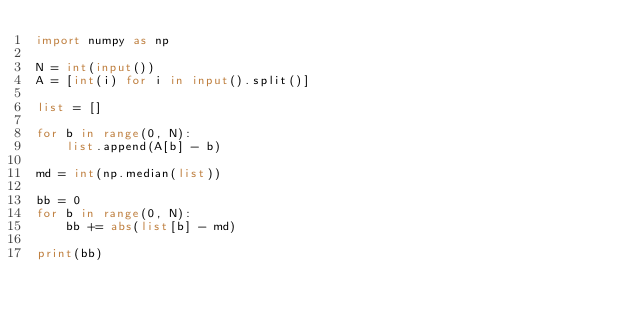<code> <loc_0><loc_0><loc_500><loc_500><_Python_>import numpy as np

N = int(input())
A = [int(i) for i in input().split()]

list = []

for b in range(0, N):
    list.append(A[b] - b)

md = int(np.median(list))

bb = 0
for b in range(0, N):
    bb += abs(list[b] - md)

print(bb)
</code> 